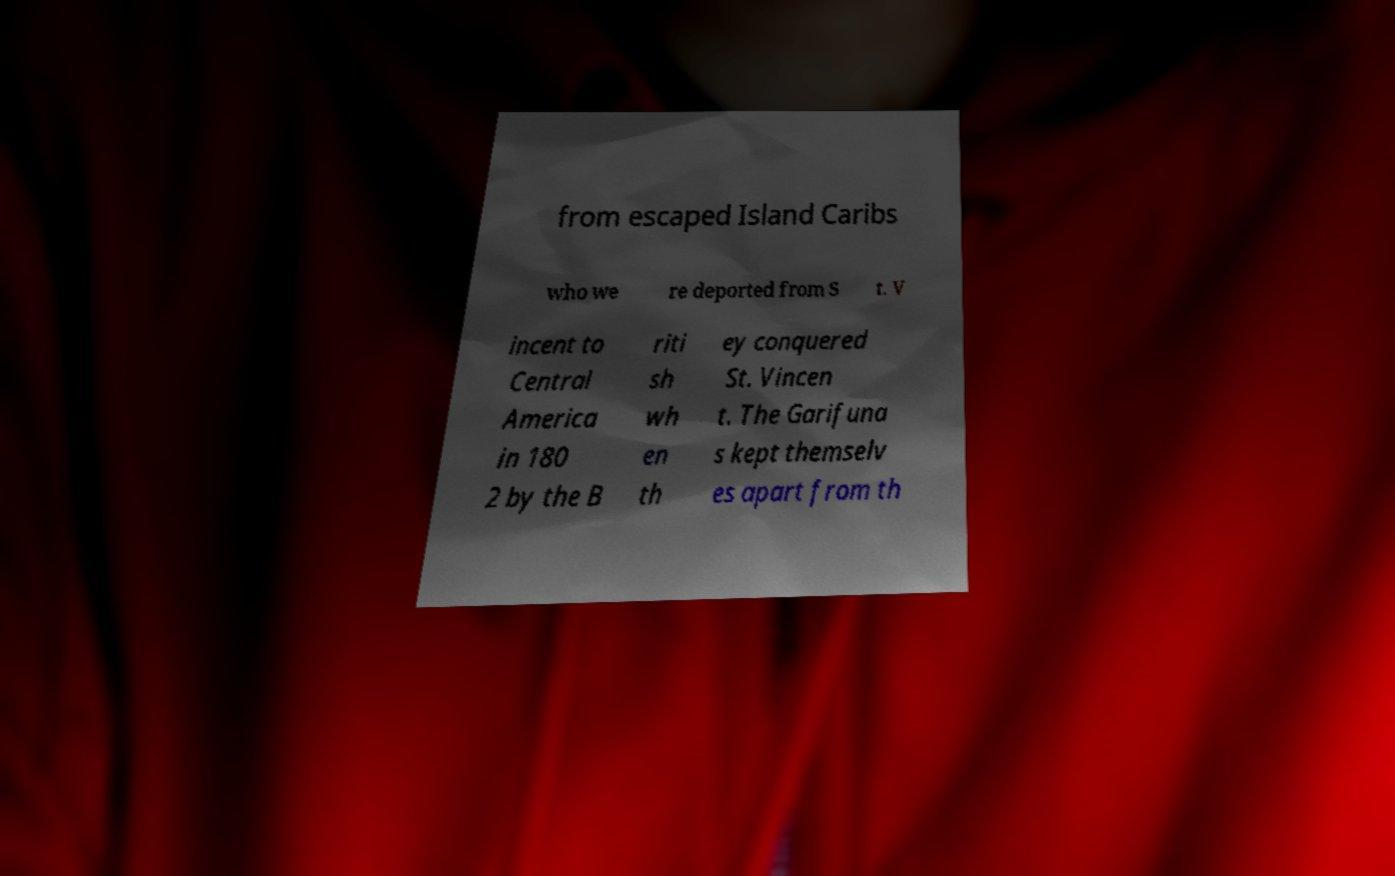Can you accurately transcribe the text from the provided image for me? from escaped Island Caribs who we re deported from S t. V incent to Central America in 180 2 by the B riti sh wh en th ey conquered St. Vincen t. The Garifuna s kept themselv es apart from th 